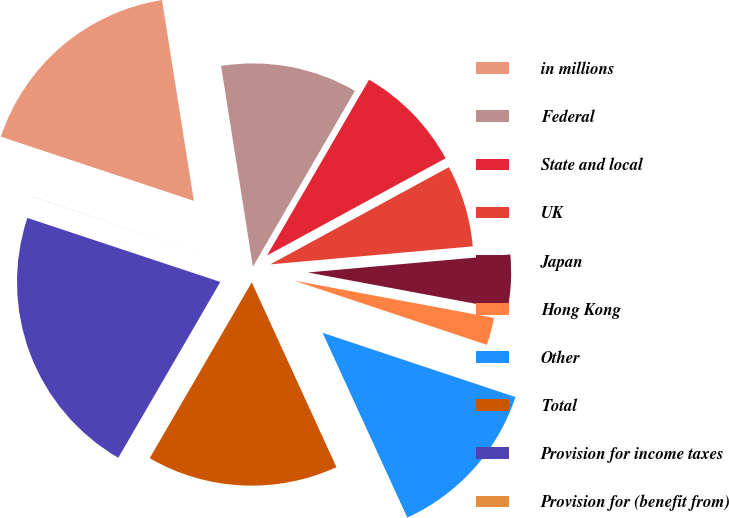Convert chart to OTSL. <chart><loc_0><loc_0><loc_500><loc_500><pie_chart><fcel>in millions<fcel>Federal<fcel>State and local<fcel>UK<fcel>Japan<fcel>Hong Kong<fcel>Other<fcel>Total<fcel>Provision for income taxes<fcel>Provision for (benefit from)<nl><fcel>17.39%<fcel>10.87%<fcel>8.7%<fcel>6.52%<fcel>4.35%<fcel>2.18%<fcel>13.04%<fcel>15.21%<fcel>21.73%<fcel>0.01%<nl></chart> 